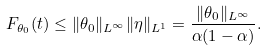Convert formula to latex. <formula><loc_0><loc_0><loc_500><loc_500>F _ { \theta _ { 0 } } ( t ) \leq \| \theta _ { 0 } \| _ { L ^ { \infty } } \| \eta \| _ { L ^ { 1 } } = \frac { \| \theta _ { 0 } \| _ { L ^ { \infty } } } { \alpha ( 1 - \alpha ) } .</formula> 